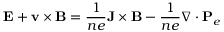Convert formula to latex. <formula><loc_0><loc_0><loc_500><loc_500>E + v \times B = \frac { 1 } { n e } J \times B - \frac { 1 } { n e } \nabla \cdot P _ { e }</formula> 